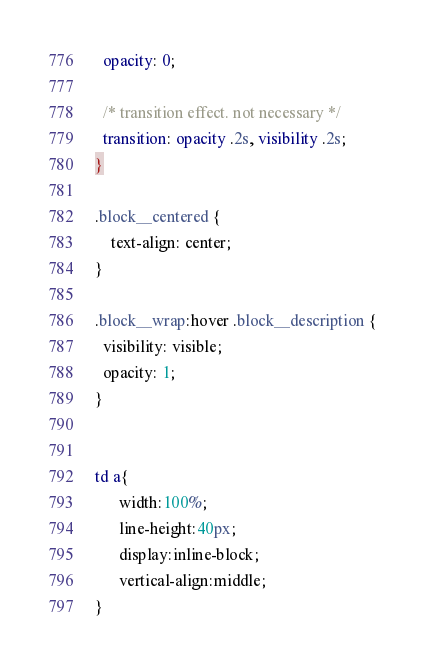<code> <loc_0><loc_0><loc_500><loc_500><_CSS_>  opacity: 0;

  /* transition effect. not necessary */
  transition: opacity .2s, visibility .2s;
}

.block__centered {
	text-align: center;
}

.block__wrap:hover .block__description {
  visibility: visible;
  opacity: 1;
}


td a{
      width:100%;
      line-height:40px;
      display:inline-block;
      vertical-align:middle;
}
</code> 